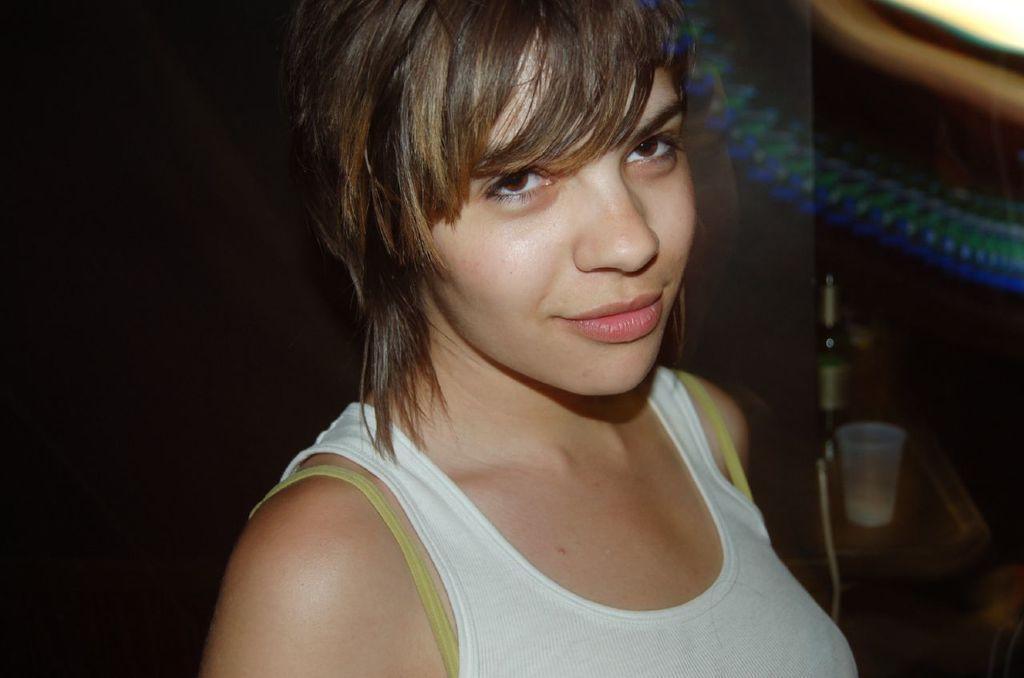How would you summarize this image in a sentence or two? In this image there is a girl wearing white T-shirt, on the left it is dark, on the right there is a table, on that table there is a bottle and a glass. 